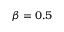Convert formula to latex. <formula><loc_0><loc_0><loc_500><loc_500>\beta = 0 . 5</formula> 